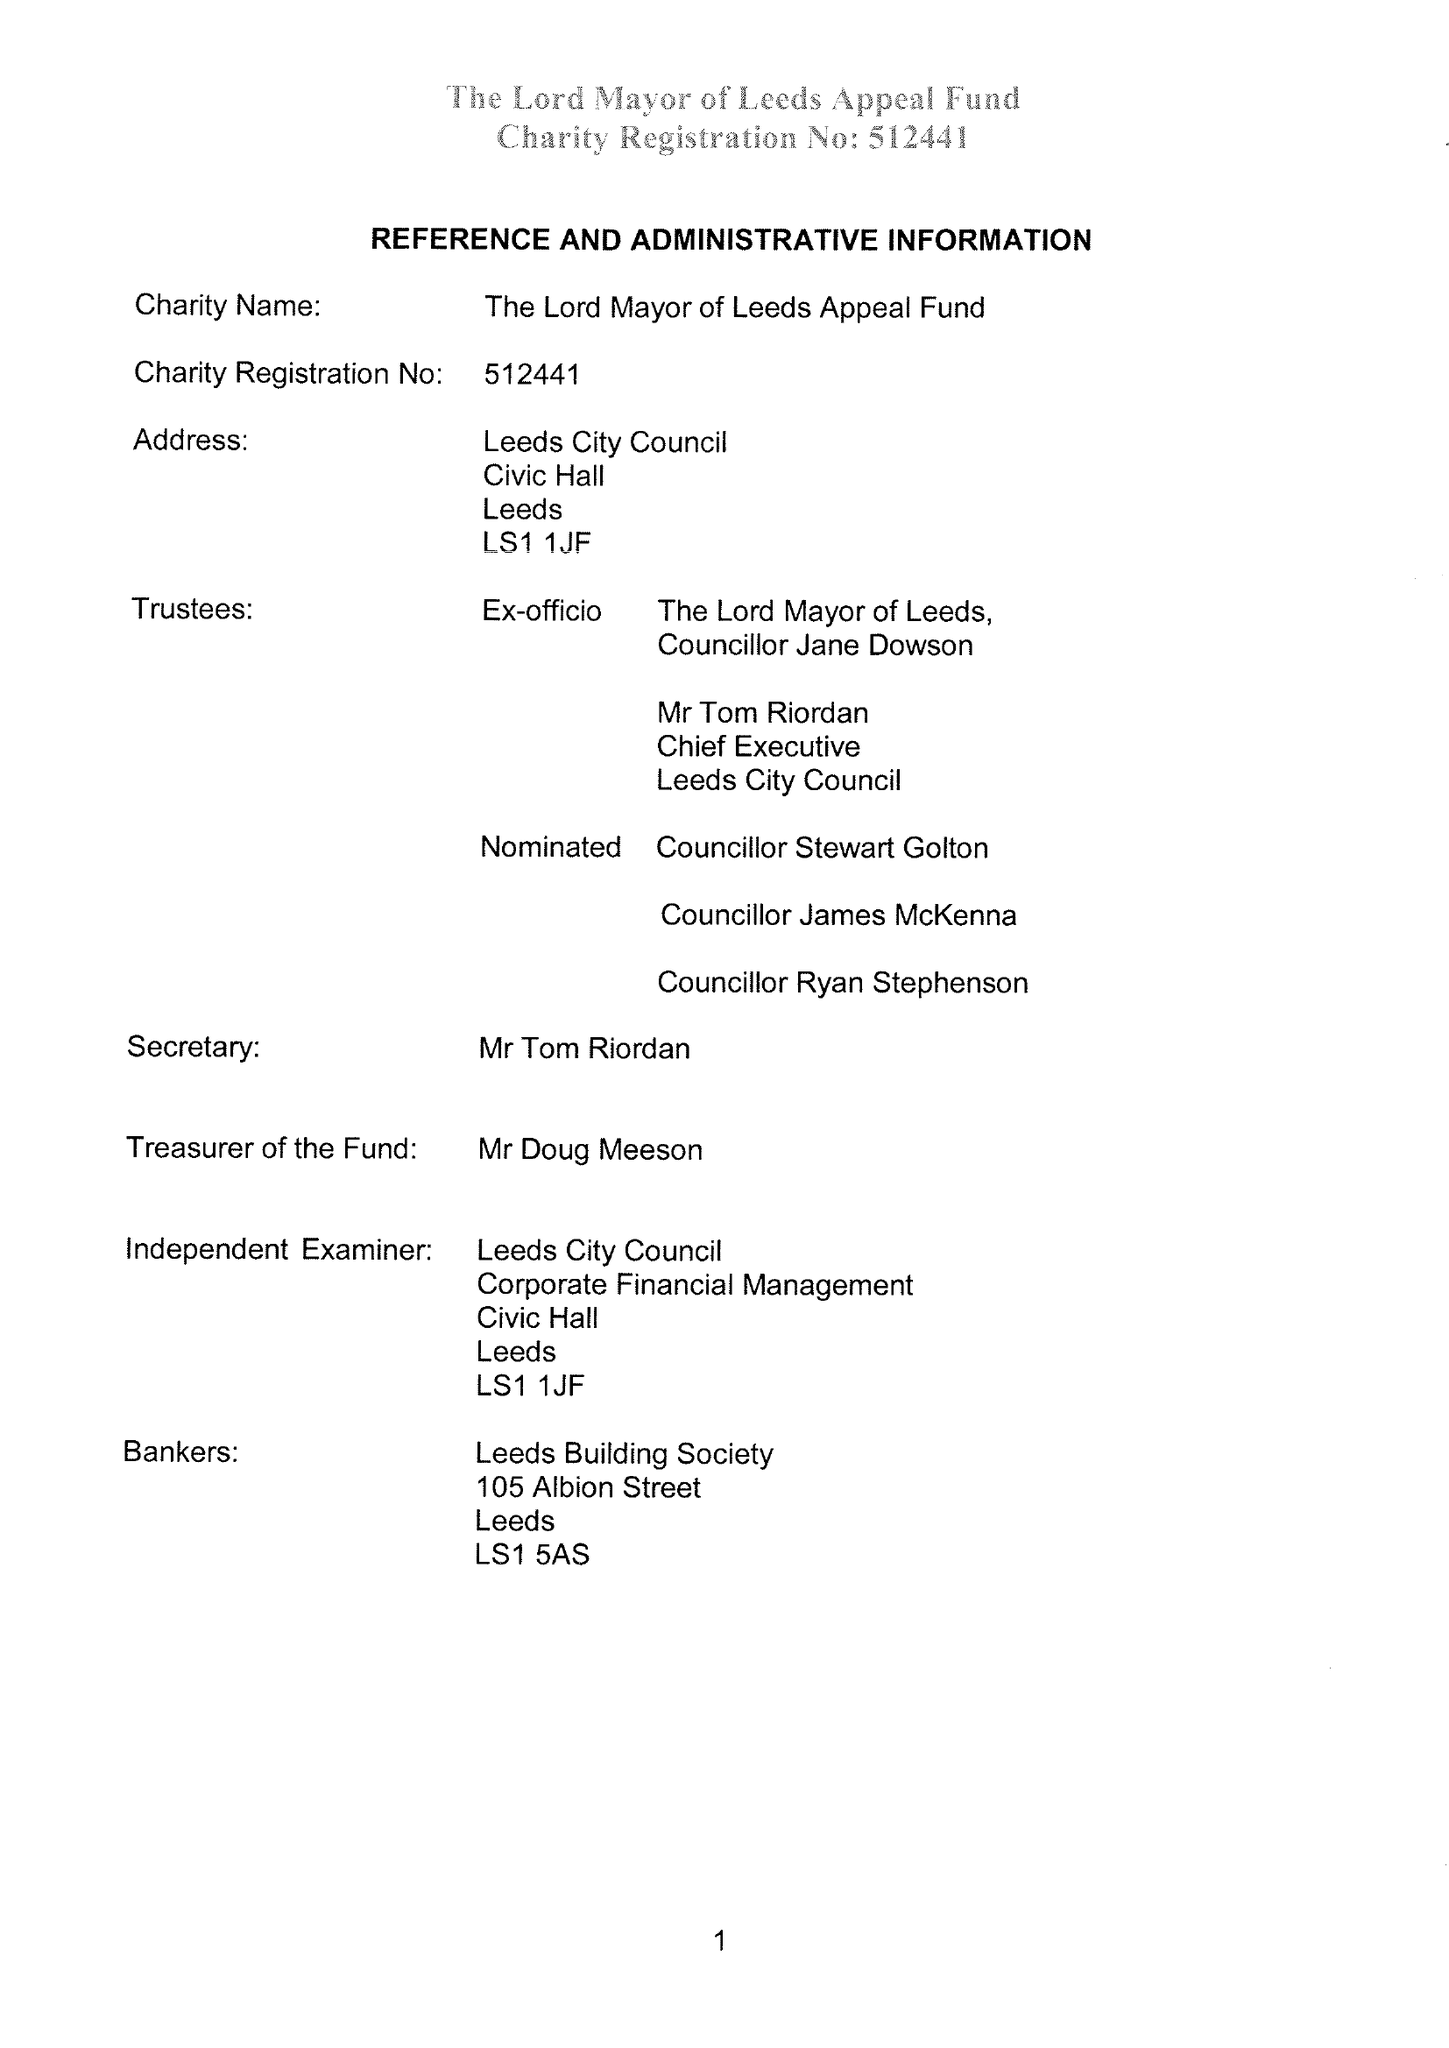What is the value for the income_annually_in_british_pounds?
Answer the question using a single word or phrase. 29945.00 